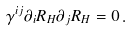Convert formula to latex. <formula><loc_0><loc_0><loc_500><loc_500>\gamma ^ { i j } \partial _ { i } R _ { H } \partial _ { j } R _ { H } = 0 \, .</formula> 